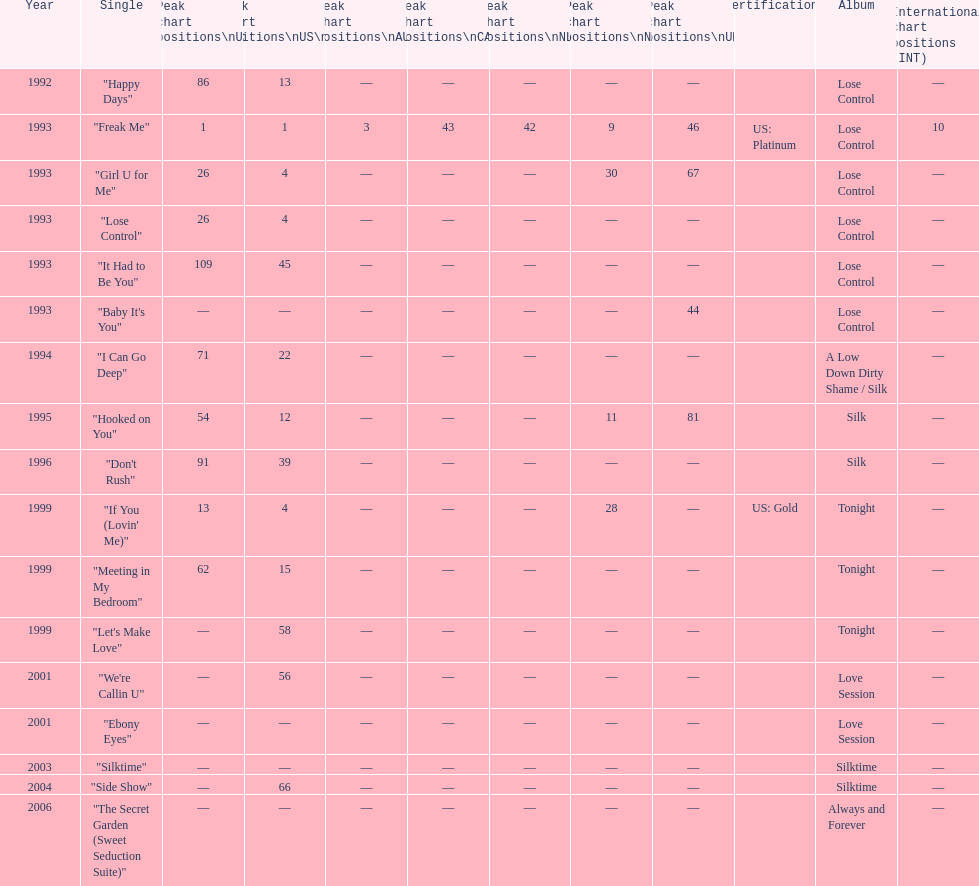Compare "i can go deep" with "don't rush". which was higher on the us and us r&b charts? "I Can Go Deep". 